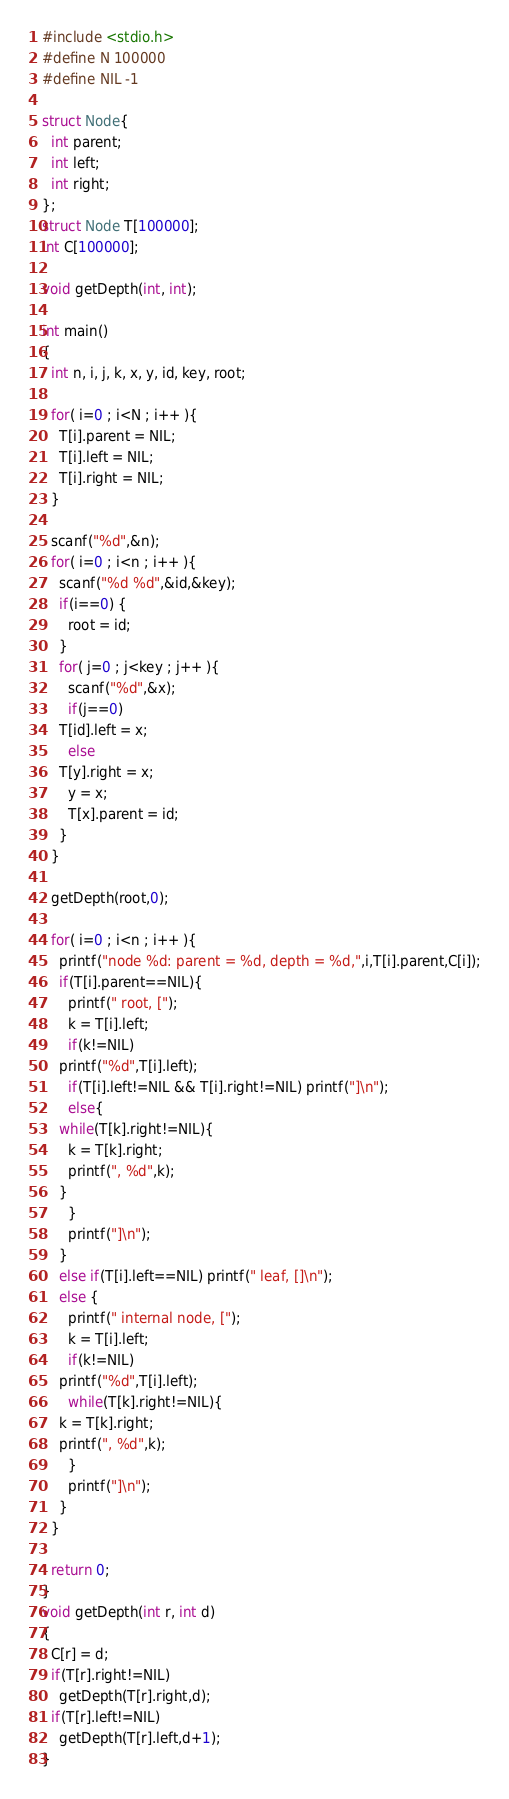<code> <loc_0><loc_0><loc_500><loc_500><_C_>#include <stdio.h>
#define N 100000
#define NIL -1

struct Node{
  int parent;
  int left;
  int right;
};
struct Node T[100000];
int C[100000];

void getDepth(int, int);

int main()
{
  int n, i, j, k, x, y, id, key, root;
  
  for( i=0 ; i<N ; i++ ){
    T[i].parent = NIL;
    T[i].left = NIL;
    T[i].right = NIL;
  }

  scanf("%d",&n);
  for( i=0 ; i<n ; i++ ){
    scanf("%d %d",&id,&key);
    if(i==0) {
      root = id;
    }
    for( j=0 ; j<key ; j++ ){
      scanf("%d",&x);
      if(j==0)
	T[id].left = x;
      else
	T[y].right = x;
      y = x;
      T[x].parent = id;
    }
  }

  getDepth(root,0);

  for( i=0 ; i<n ; i++ ){
    printf("node %d: parent = %d, depth = %d,",i,T[i].parent,C[i]);
    if(T[i].parent==NIL){
      printf(" root, [");
      k = T[i].left;
      if(k!=NIL)
	printf("%d",T[i].left);
      if(T[i].left!=NIL && T[i].right!=NIL) printf("]\n");
      else{
	while(T[k].right!=NIL){
	  k = T[k].right;
	  printf(", %d",k);
	}
      }
      printf("]\n");
    }
    else if(T[i].left==NIL) printf(" leaf, []\n");
    else {
      printf(" internal node, [");
      k = T[i].left;
      if(k!=NIL)
	printf("%d",T[i].left);
      while(T[k].right!=NIL){
	k = T[k].right;
	printf(", %d",k);
      }
      printf("]\n");
    }
  }

  return 0;
}
void getDepth(int r, int d)
{
  C[r] = d;
  if(T[r].right!=NIL)
    getDepth(T[r].right,d);
  if(T[r].left!=NIL)
    getDepth(T[r].left,d+1);
}</code> 